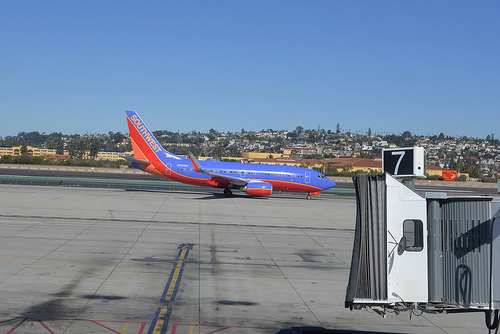<image>
Can you confirm if the plane is in the sky? No. The plane is not contained within the sky. These objects have a different spatial relationship. 